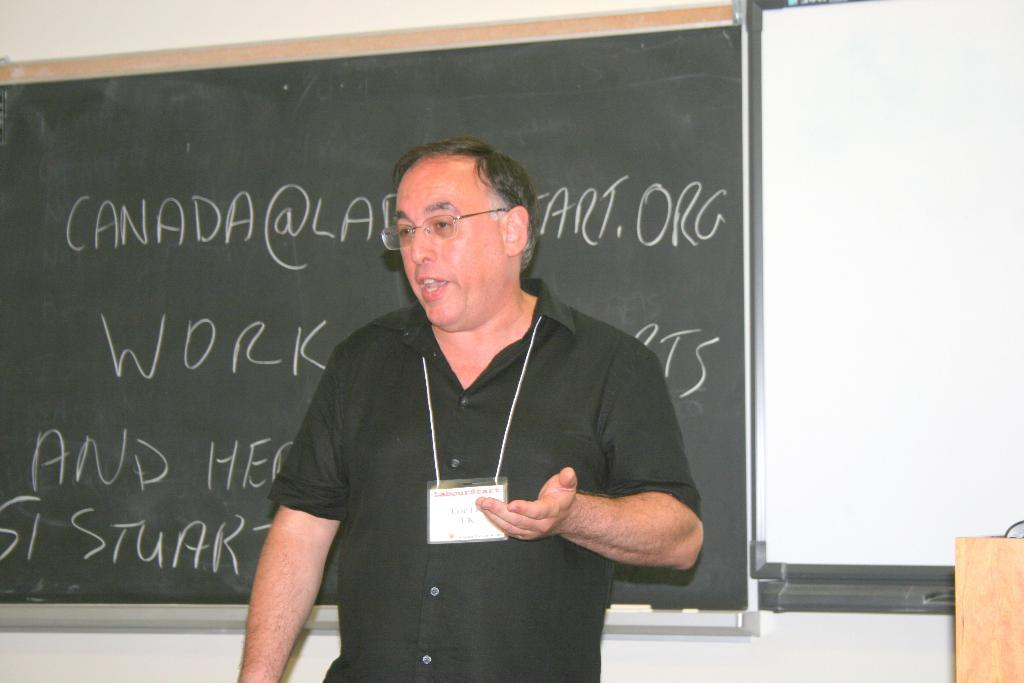What is the man in the image doing? The man is standing and speaking in the image. Can you describe what the man is wearing? The man is wearing an ID card. What type of surfaces are present in the image for writing or displaying information? There is a blackboard and a whiteboard in the image. Is there any furniture or structure in the image that the man might be using? Yes, there is a podium in the image. What is written on the blackboard in the image? There is text written on the blackboard in the image. What type of vacation is the man planning based on the image? There is no information about a vacation in the image; it shows a man standing and speaking with a blackboard, whiteboard, and podium present. 